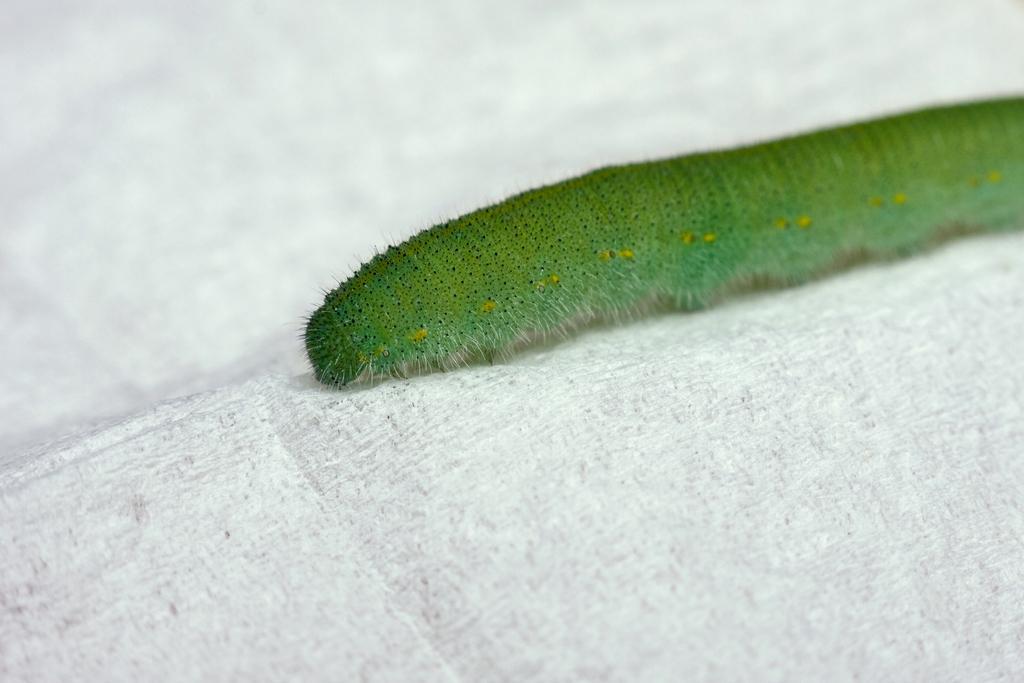How would you summarize this image in a sentence or two? This is a zoomed in picture. in the center there is a green color insect on a white color object. 